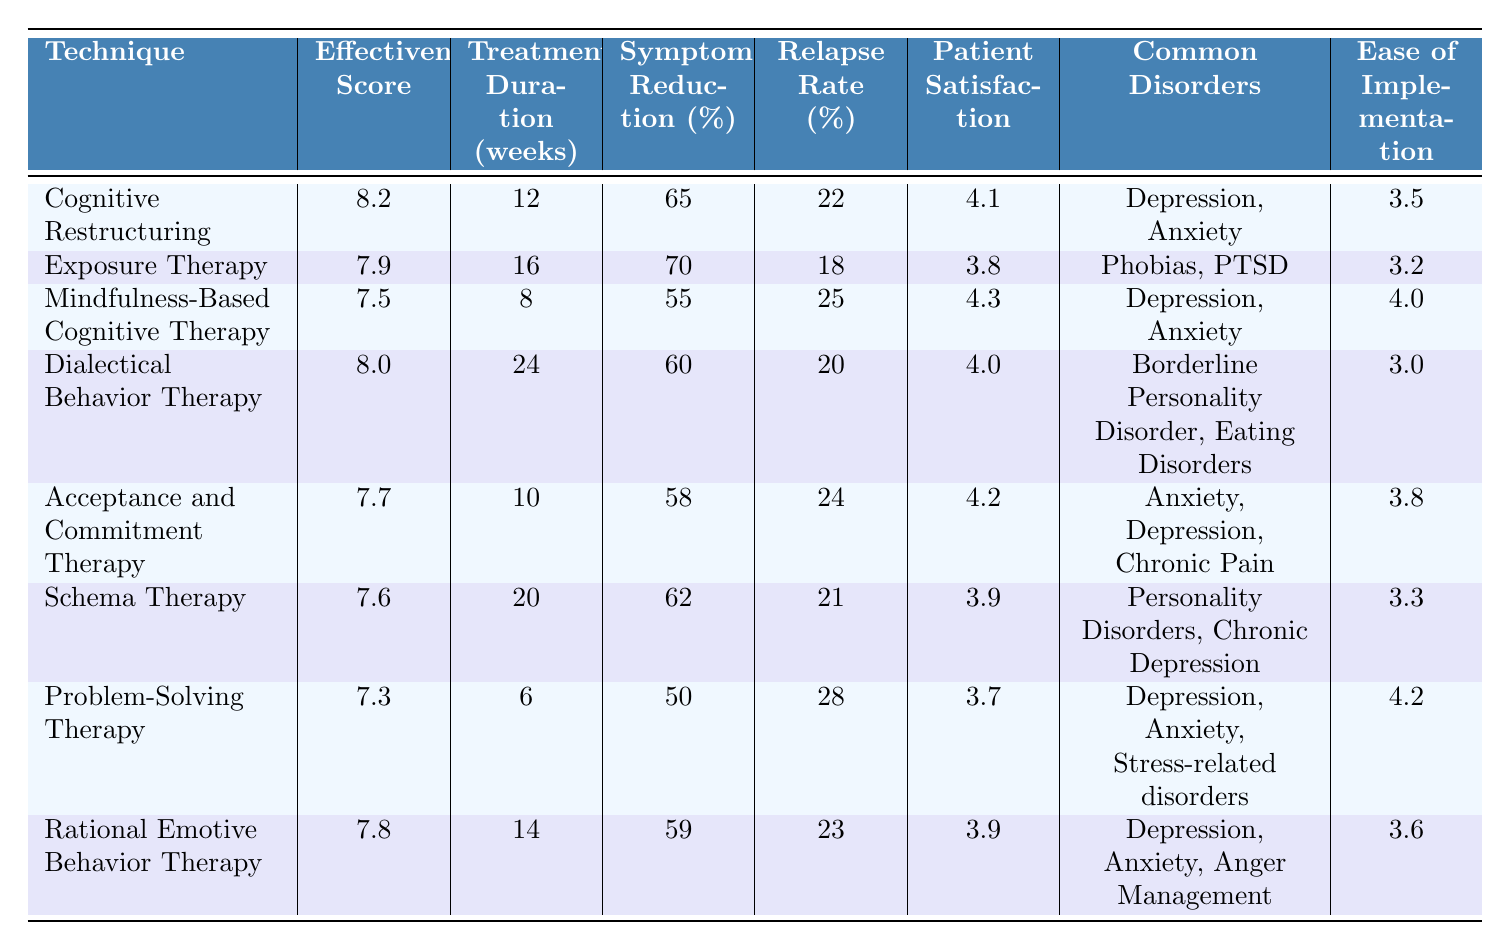What is the effectiveness score of Cognitive Restructuring? The effectiveness score is given directly in the table under the "Effectiveness Score" column for Cognitive Restructuring. Referring to the entry, the score is 8.2.
Answer: 8.2 Which therapy has the highest patient satisfaction? By checking the "Patient Satisfaction" column, we see that Mindfulness-Based Cognitive Therapy has a score of 4.3, which is the highest compared to others in the table.
Answer: 4.3 How long is the treatment duration for Schema Therapy? The treatment duration for Schema Therapy is found in the "Treatment Duration (weeks)" column, where it is listed as 20 weeks.
Answer: 20 weeks What is the symptom reduction percentage for Exposure Therapy? Exposure Therapy shows a symptom reduction percentage listed in the corresponding column as 70%.
Answer: 70% Which technique has the lowest ease of implementation score? Looking in the "Ease of Implementation" column, we see that Dialectical Behavior Therapy has the lowest score of 3.0.
Answer: 3.0 Calculate the average symptom reduction percentage for all therapies listed. To find the average, we add the symptom reduction percentages: 65 + 70 + 55 + 60 + 58 + 62 + 50 + 59 = 409. Then, we divide by the number of techniques (8): 409 / 8 = 51.125.
Answer: 51.125 Is it true that Dialectical Behavior Therapy has a higher effectiveness score than Acceptance and Commitment Therapy? We compare the effectiveness scores: Dialectical Behavior Therapy has 8.0 while Acceptance and Commitment Therapy has 7.7. Since 8.0 is greater than 7.7, the statement is true.
Answer: Yes Which therapy has the highest relapse rate, and what is that rate? Checking the "Relapse Rate" column, Problem-Solving Therapy has the highest rate at 28%.
Answer: Problem-Solving Therapy, 28% How do the effectiveness scores of cognitive therapies correlate with patient satisfaction? We evaluate the effectiveness scores against patient satisfaction ratings, finding a general trend where higher effectiveness scores correlate with higher satisfaction ratings (e.g., Cognitive Restructuring with 8.2 effectiveness has 4.1 satisfaction). However, not all follow this rule strictly, necessitating careful evaluation of each.
Answer: Generally positive correlation, but not strict 